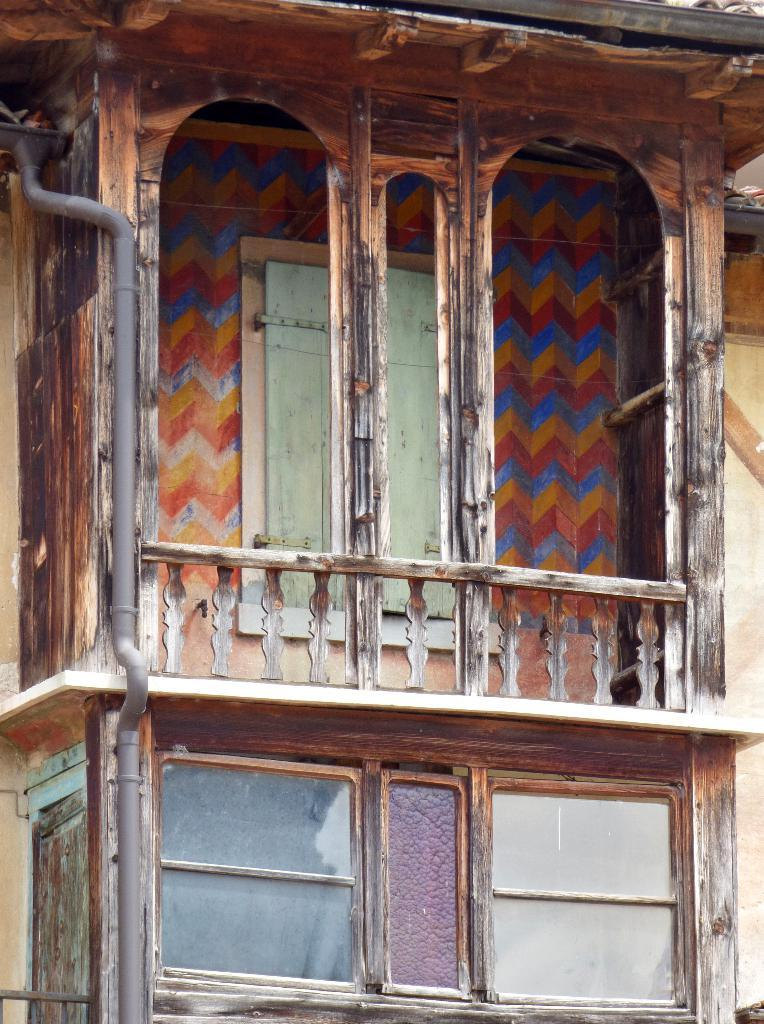What type of structure can be seen in the image? There is a pipe, railing, walls, and windows visible in the image. What might be used for support or safety in the image? The railing in the image can be used for support or safety. What can be seen through the windows in the image? The contents or view outside the windows cannot be determined from the provided facts. What might be used for enclosing or dividing spaces in the image? The walls in the image can be used for enclosing or dividing spaces. How many balls are present in the image? There is no mention of balls in the provided facts, so it cannot be determined if any are present in the image. 